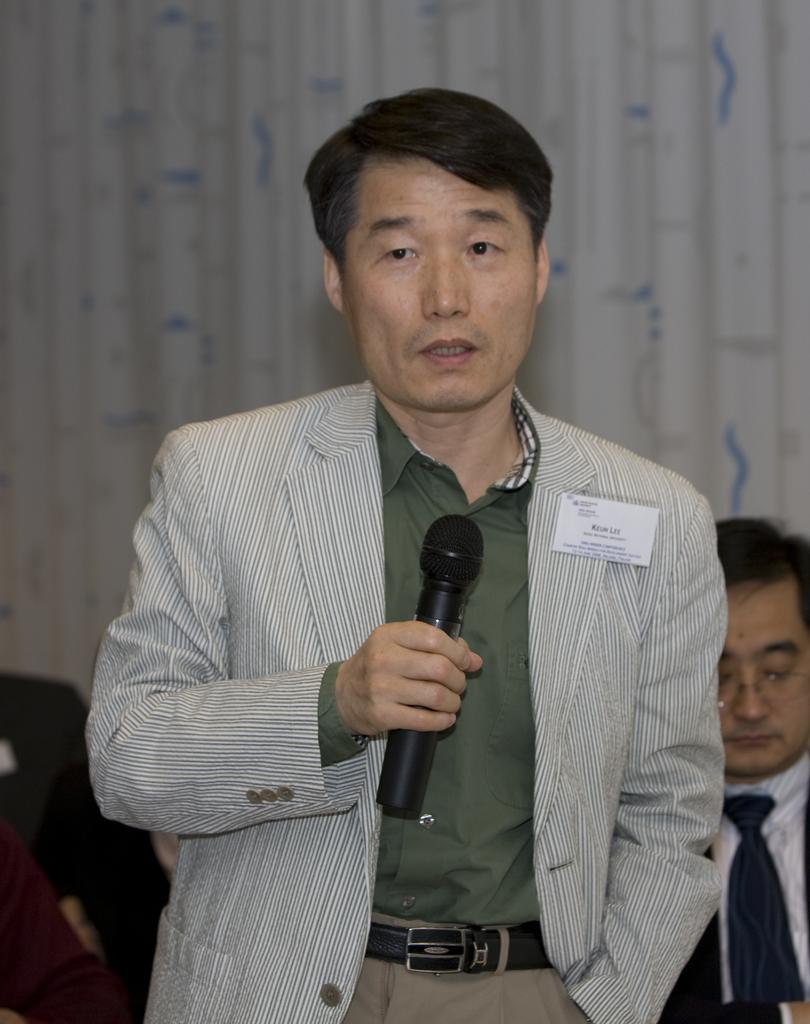What is the man in the image holding? The man is holding a microphone in the image. What is the man with the microphone doing? The man is talking, as indicated by his open mouth. Can you describe the position of the other man in the image? There is another man sitting on a chair in the image. What can be seen in the background of the image? There is a white-colored curtain in the background of the image. What type of cherries can be seen on the library shelves in the image? There is no mention of cherries or a library in the image; it features a man holding a microphone and another man sitting on a chair with a white-colored curtain in the background. 